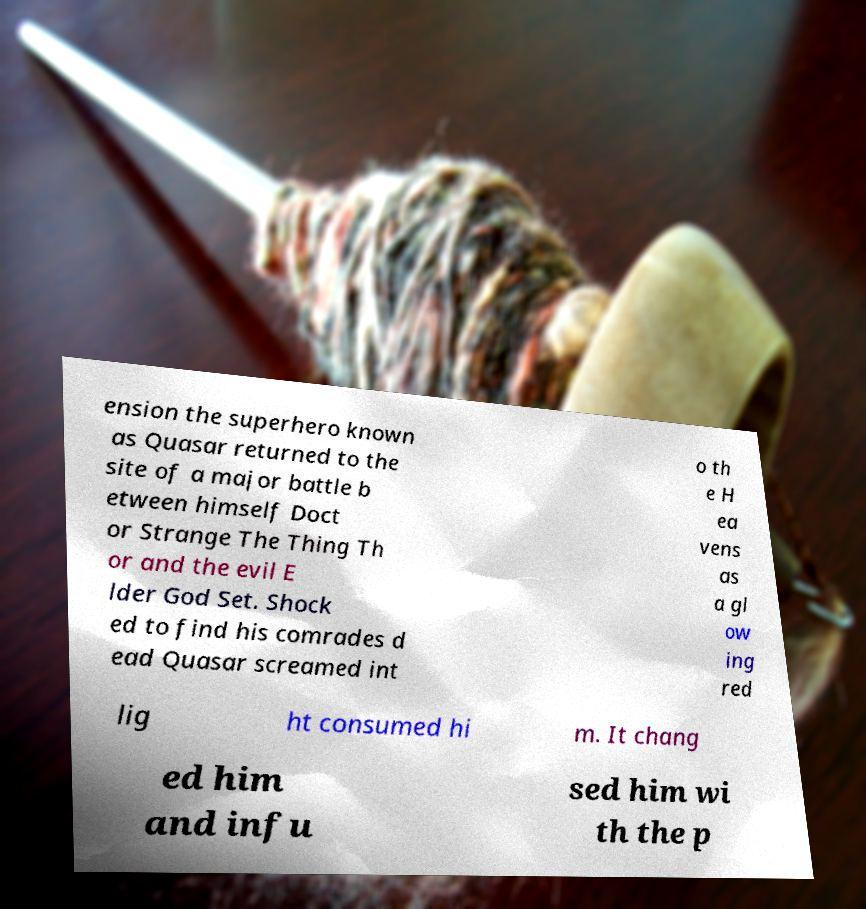Can you read and provide the text displayed in the image?This photo seems to have some interesting text. Can you extract and type it out for me? ension the superhero known as Quasar returned to the site of a major battle b etween himself Doct or Strange The Thing Th or and the evil E lder God Set. Shock ed to find his comrades d ead Quasar screamed int o th e H ea vens as a gl ow ing red lig ht consumed hi m. It chang ed him and infu sed him wi th the p 